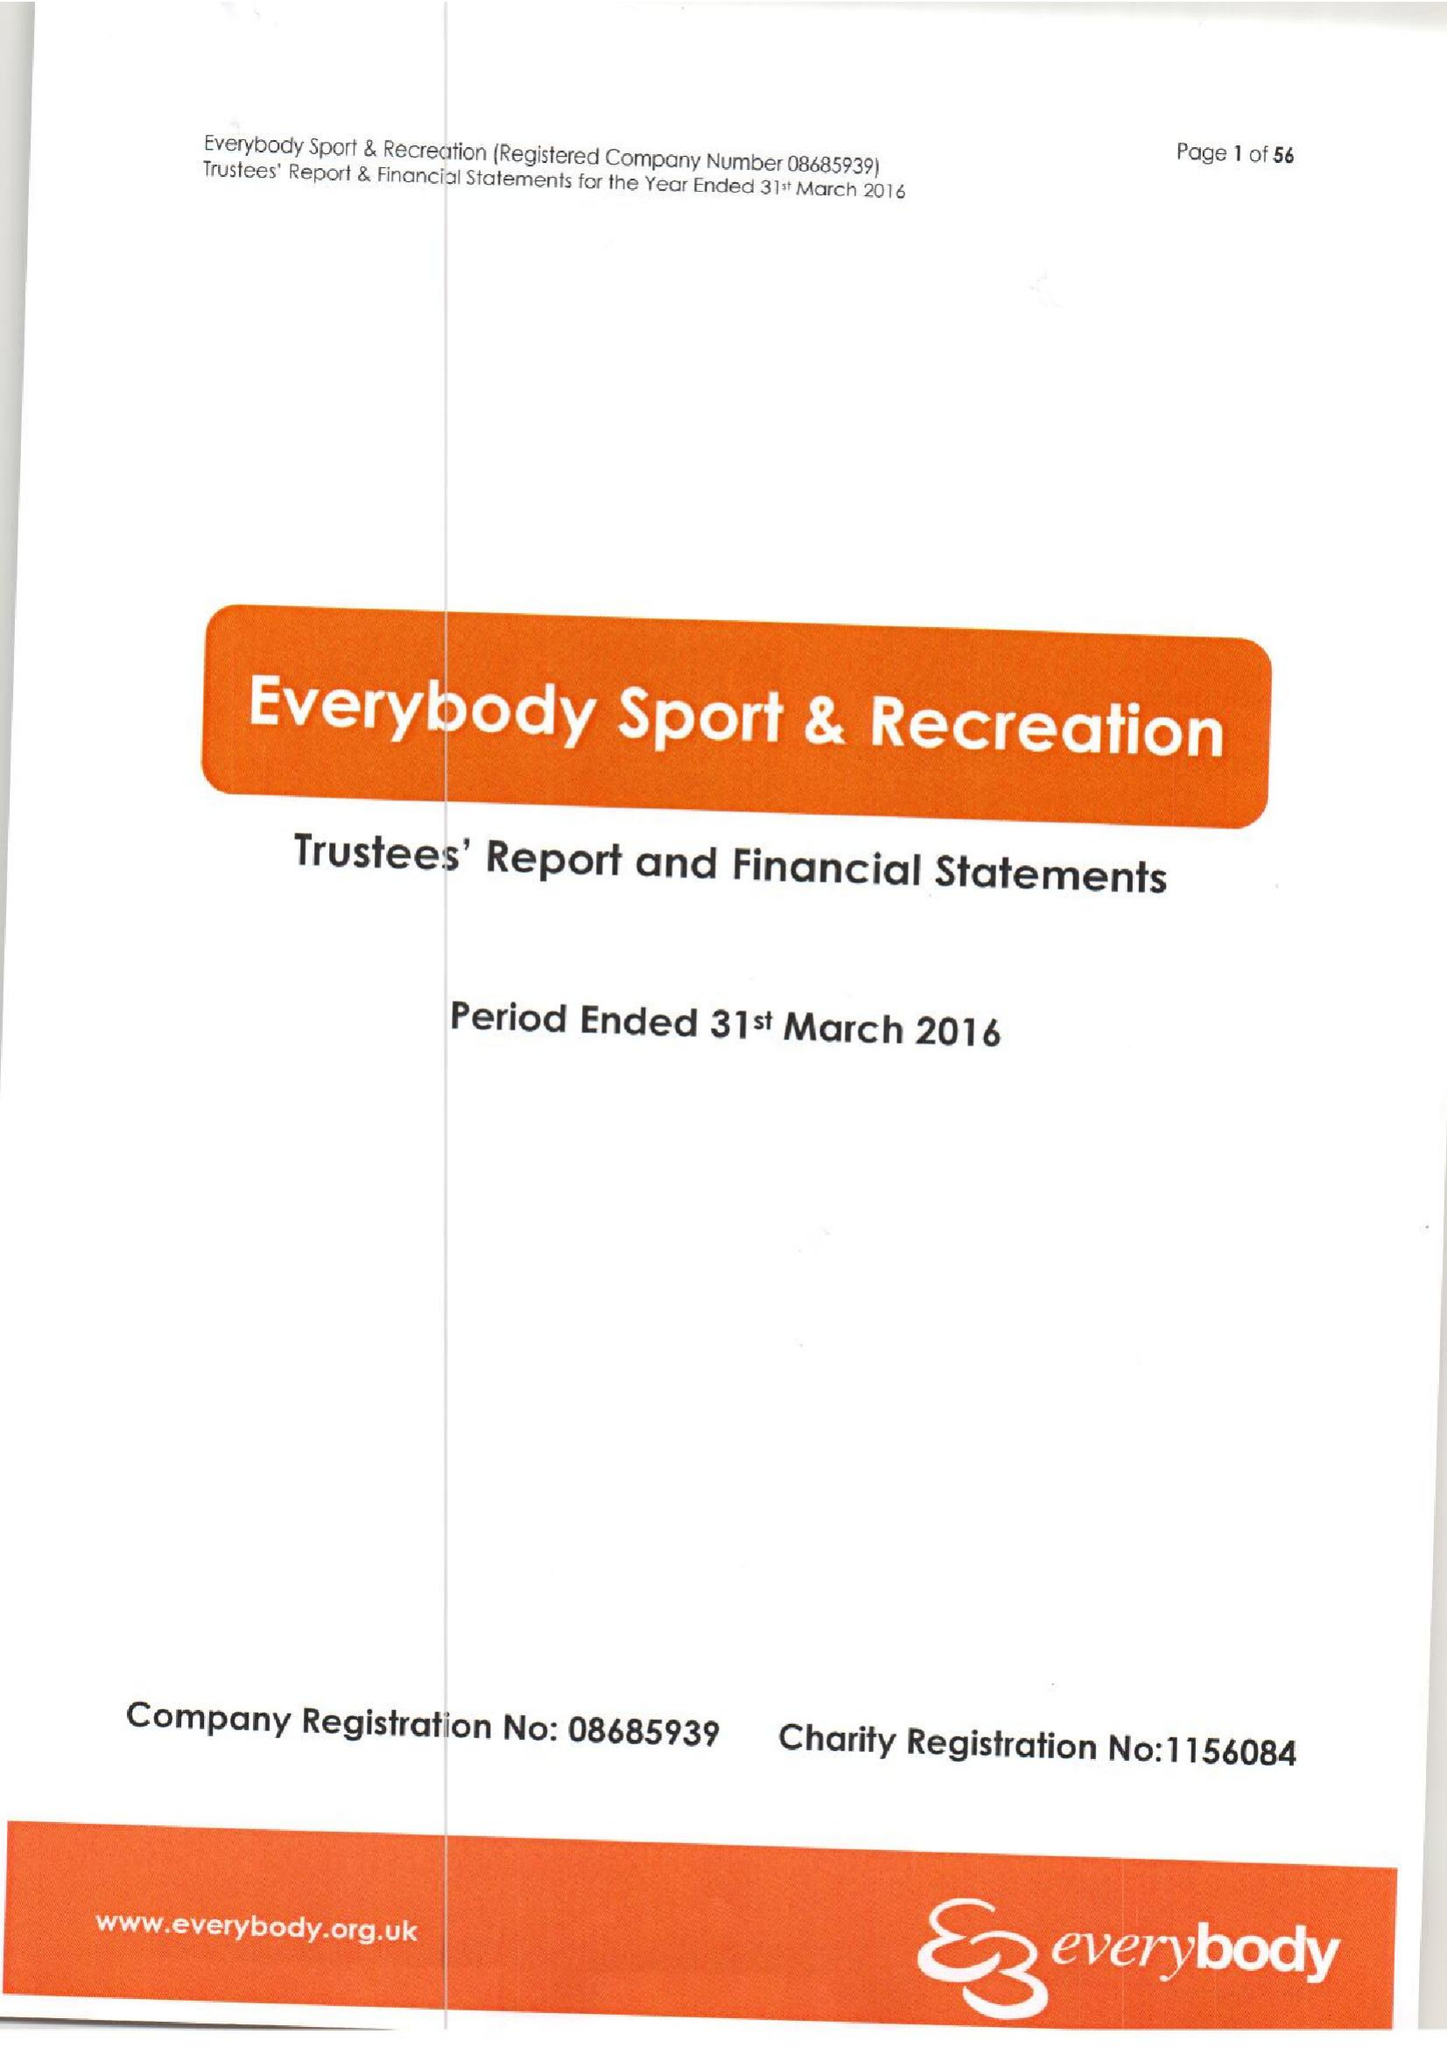What is the value for the income_annually_in_british_pounds?
Answer the question using a single word or phrase. 13634670.00 